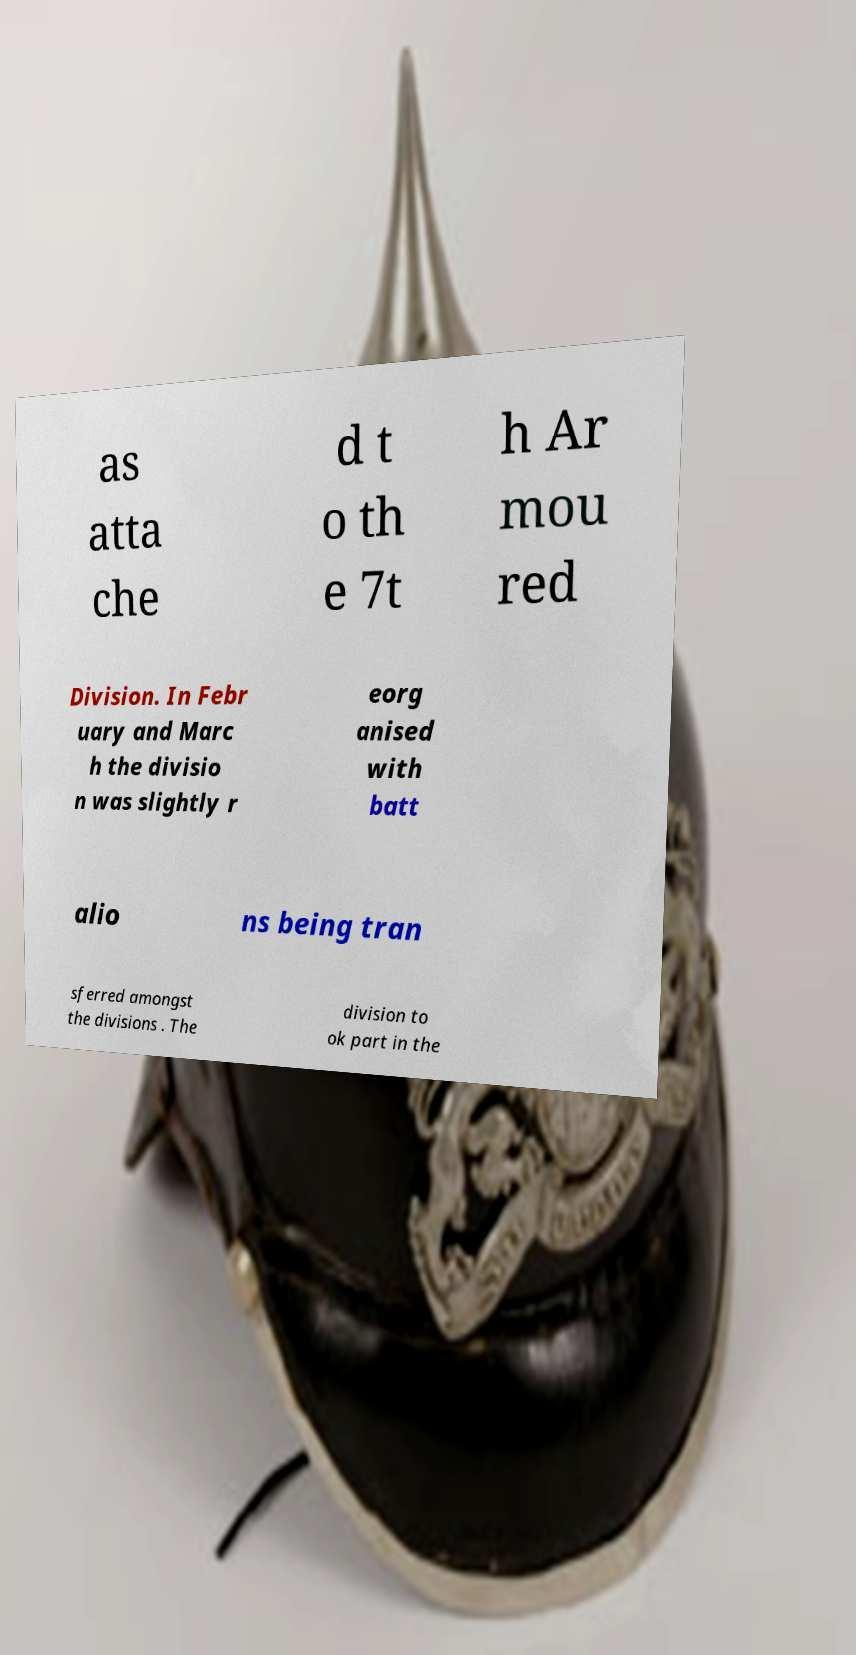Can you read and provide the text displayed in the image?This photo seems to have some interesting text. Can you extract and type it out for me? as atta che d t o th e 7t h Ar mou red Division. In Febr uary and Marc h the divisio n was slightly r eorg anised with batt alio ns being tran sferred amongst the divisions . The division to ok part in the 